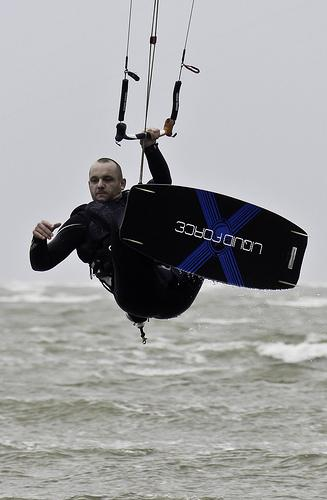Mention what words are written under the surfing board. The words "force" and "loud" are written under the surfing board. Point out the features of the man's wetsuit. The wetsuit is black, and the man is wearing a black vest over it while surfing. Describe any unique or identifiable features of the wave the surfer is riding. The wave has white foam and white caps, making it distinctive and visually appealing. Are there any familiar items or scenes that can be used to describe the water below the surfing man? Yes, the water has white caps, similar to waves in a lake, and it appears to be dark green. What does the surfboard the man is riding look like, and what is on it? The surfboard is black and blue with words, a blue X, and a long white sticker on the bottom. Describe the surfer's facial features and hairstyle. The surfer has a receding hairline, two eyes, one being the left eye and the other being the right eye. What objects or features are associated with the surfer's hands and arms? The surfer's left hand is gripping a bar, and his right hand is in the air, with identifiable fingers. What kind of water body is the man surfing on, and what color is the water? The man is surfing on a lake, and the water is a dark green color. Explain the surfboard's design and its manufacturer details in the image. The surfboard has a blue X decal, words like "force" and "loud" written on it, and the name of the manufacturer is visible. Identify a detail about the surfer that indicates he has a safety precaution in place. A safety clip is attached to the surfer's belt, securing him while he rides the waves. 